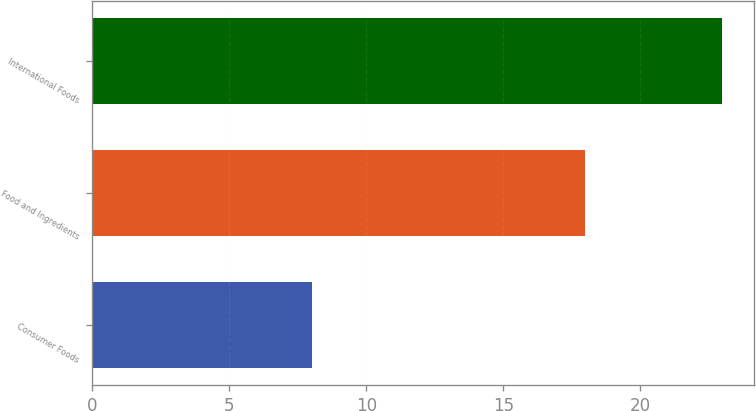Convert chart to OTSL. <chart><loc_0><loc_0><loc_500><loc_500><bar_chart><fcel>Consumer Foods<fcel>Food and Ingredients<fcel>International Foods<nl><fcel>8<fcel>18<fcel>23<nl></chart> 